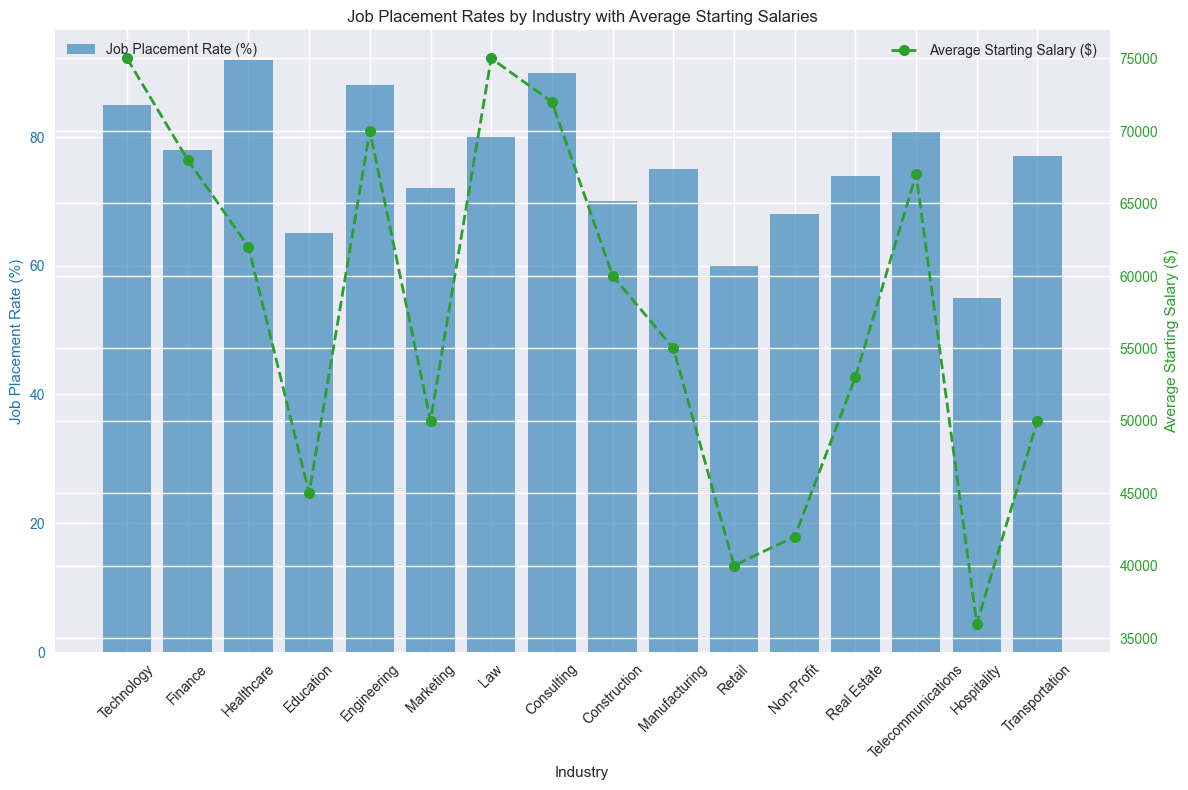How many industries have a job placement rate higher than 80%? There are 7 industries with job placement rates higher than 80%: Technology, Healthcare, Engineering, Law, Consulting, Telecommunications, and Transportation.
Answer: 7 Which industry has the highest average starting salary, and what is that salary? The Law industry has the highest average starting salary, which is $75,000.
Answer: Law, $75,000 Compare the job placement rates of Marketing and Construction industries. The Job Placement Rate for Marketing is 72%, whereas for Construction, it is 70%. Therefore, Marketing has a higher job placement rate than Construction.
Answer: Marketing has a higher rate Which industry has the lowest job placement rate, and what is that rate? The Hospitality industry has the lowest job placement rate, which is 55%.
Answer: Hospitality, 55% What is the difference in job placement rate between the industry with the highest and the industry with the lowest rates? The industry with the highest job placement rate is Healthcare at 92%, and the industry with the lowest is Hospitality at 55%. The difference is 92% - 55% = 37%.
Answer: 37% What is the average of the average starting salaries for Technology, Finance, and Engineering industries? The average starting salaries are $75,000 for Technology, $68,000 for Finance, and $70,000 for Engineering. The average is ($75,000 + $68,000 + $70,000) / 3 = $71,000.
Answer: $71,000 Which industry has both a job placement rate higher than 80% and an average starting salary higher than $70,000? The Law industry has a job placement rate of 80% and an average starting salary of $75,000. It satisfies both conditions.
Answer: Law What is the visual relationship between the job placement rate bars and the average starting salary line for the Construction industry? For Construction, the job placement rate bar is at 70%, and the average starting salary line is at $60,000, illustrated with a bar height at 70% and a line marker (green circle) at $60,000.
Answer: 70%, $60,000 What's the sum of the job placement rates for Education and Non-Profit industries? The job placement rate for Education is 65%, and for Non-Profit, it is 68%. The sum is 65% + 68% = 133%.
Answer: 133% Is there an industry with a job placement rate lower than 60% yet an average starting salary more than $40,000? No industry meets both conditions. Hospitality has a job placement rate of 55% but an average starting salary of $36,000, which is less than $40,000.
Answer: No 